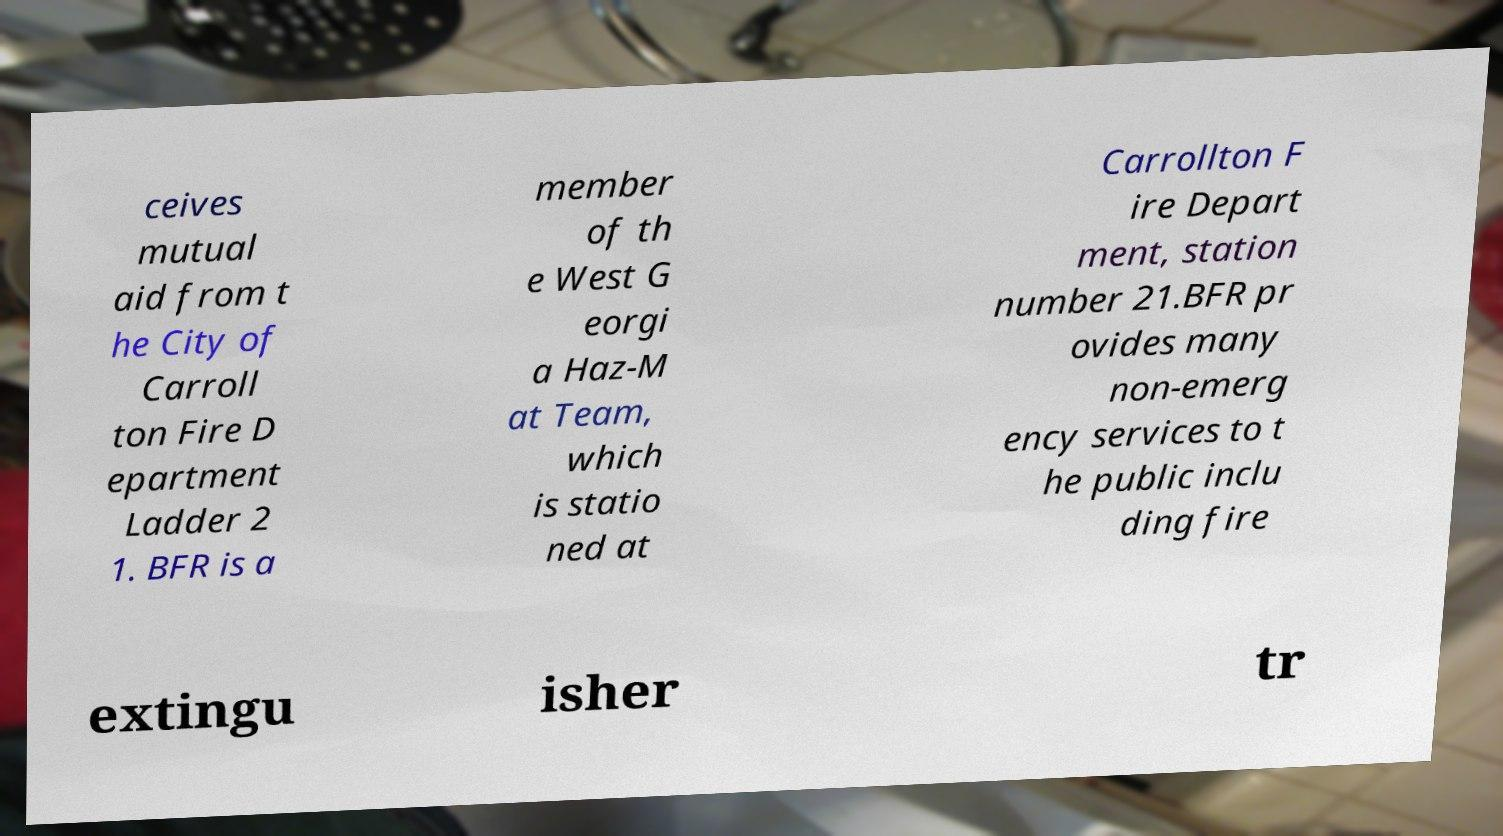There's text embedded in this image that I need extracted. Can you transcribe it verbatim? ceives mutual aid from t he City of Carroll ton Fire D epartment Ladder 2 1. BFR is a member of th e West G eorgi a Haz-M at Team, which is statio ned at Carrollton F ire Depart ment, station number 21.BFR pr ovides many non-emerg ency services to t he public inclu ding fire extingu isher tr 